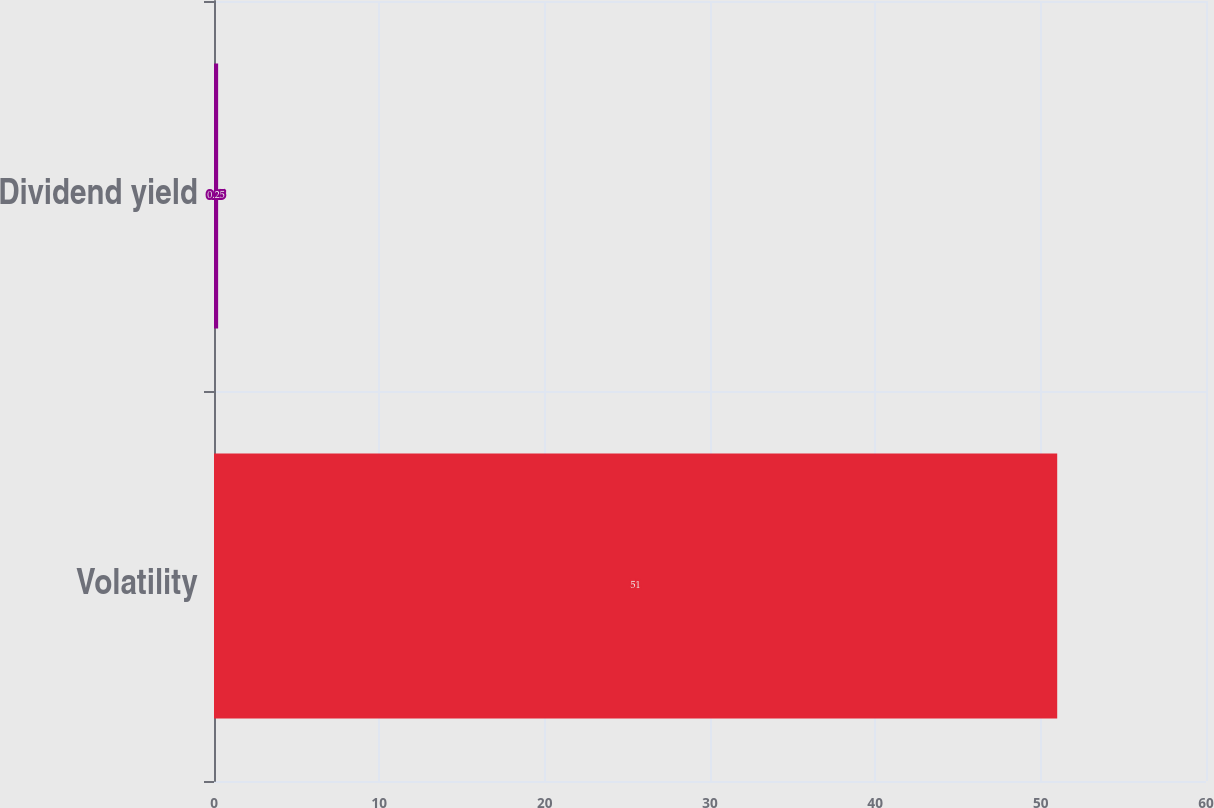<chart> <loc_0><loc_0><loc_500><loc_500><bar_chart><fcel>Volatility<fcel>Dividend yield<nl><fcel>51<fcel>0.25<nl></chart> 